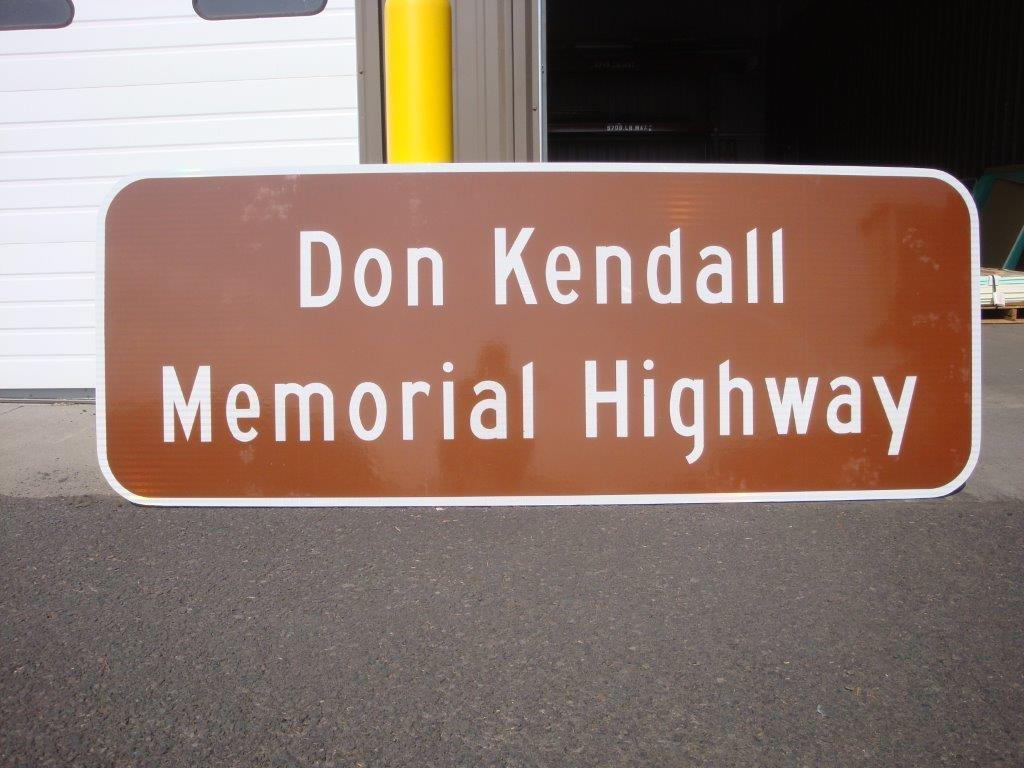Provide a one-sentence caption for the provided image. A brown sign in front of a garage that says Don Kendall memorial highway. 